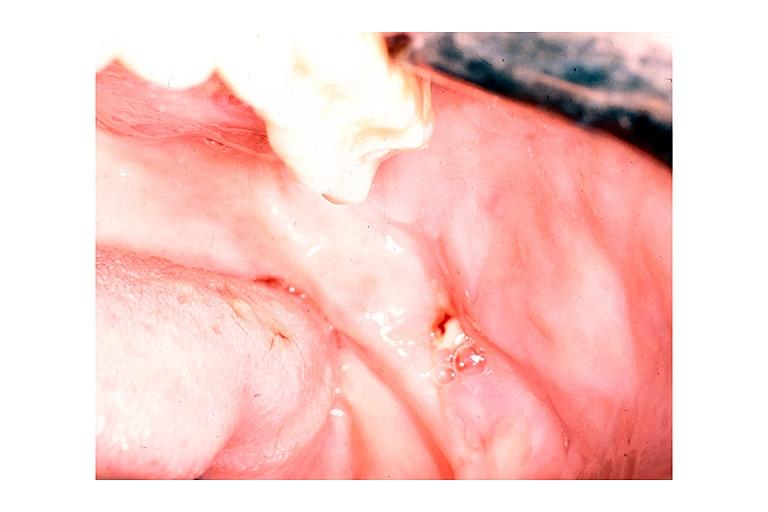does polycystic disease show chronic osteomyelitis?
Answer the question using a single word or phrase. No 